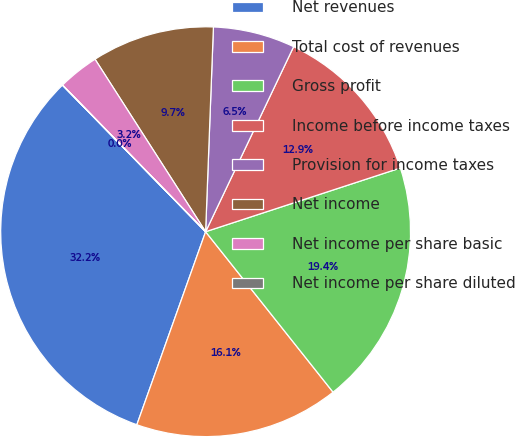Convert chart. <chart><loc_0><loc_0><loc_500><loc_500><pie_chart><fcel>Net revenues<fcel>Total cost of revenues<fcel>Gross profit<fcel>Income before income taxes<fcel>Provision for income taxes<fcel>Net income<fcel>Net income per share basic<fcel>Net income per share diluted<nl><fcel>32.24%<fcel>16.13%<fcel>19.35%<fcel>12.9%<fcel>6.46%<fcel>9.68%<fcel>3.23%<fcel>0.01%<nl></chart> 